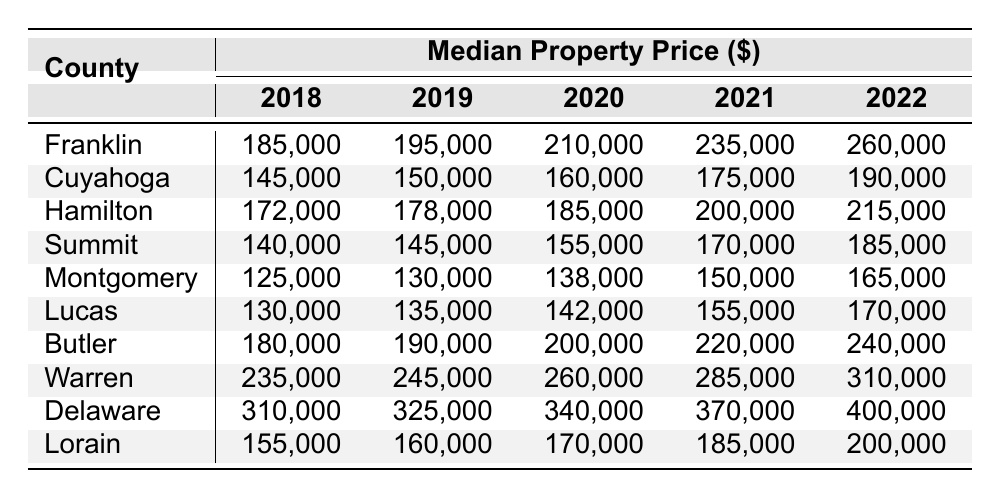What was the median property price in Franklin County in 2020? The table shows that the median property price in Franklin County for 2020 is 210,000.
Answer: 210,000 Which county had the highest property price in 2022? According to the table, Delaware County had the highest median property price of 400,000 in 2022.
Answer: Delaware What is the difference in median property prices between Hamilton County in 2018 and 2022? In 2018, Hamilton County's price was 172,000, and in 2022 it was 215,000. The difference is 215,000 - 172,000 = 43,000.
Answer: 43,000 What was the increase in median property price for Cuyahoga County from 2019 to 2022? The price in Cuyahoga County was 150,000 in 2019 and rose to 190,000 in 2022. The increase is 190,000 - 150,000 = 40,000.
Answer: 40,000 True or False: The property price in Montgomery County decreased from 2018 to 2019. In the table, the prices show an increase from 125,000 in 2018 to 130,000 in 2019, indicating a rise, not a decrease.
Answer: False What is the average property price in Warren County over the five years (2018 to 2022)? The prices for Warren County are 235,000, 245,000, 260,000, 285,000, and 310,000. To find the average, sum these (235+245+260+285+310)=1335, then divide by 5: 1335/5 = 267.
Answer: 267,000 Which county had the lowest median property price in 2021? The table indicates that Montgomery County had the lowest median price in 2021 at 150,000.
Answer: Montgomery What was the total increase in median property prices for Lucas County from 2018 to 2022? For Lucas County, the prices changed from 130,000 in 2018 to 170,000 in 2022. The total increase is 170,000 - 130,000 = 40,000.
Answer: 40,000 Compare Butler County’s property prices from 2018 to 2022. How much did it increase? Butler County's prices were 180,000 in 2018 and rose to 240,000 in 2022. Thus, the increase is 240,000 - 180,000 = 60,000.
Answer: 60,000 Identify the year with the largest single-year increase in median property price for Summit County. Analyzing Summit County, the prices increased from 140,000 in 2018 to 145,000 in 2019, then 155,000 in 2020, 170,000 in 2021, and finally 185,000 in 2022. The largest increase was from 170,000 to 185,000 (15,000) between 2021 and 2022.
Answer: 15,000 